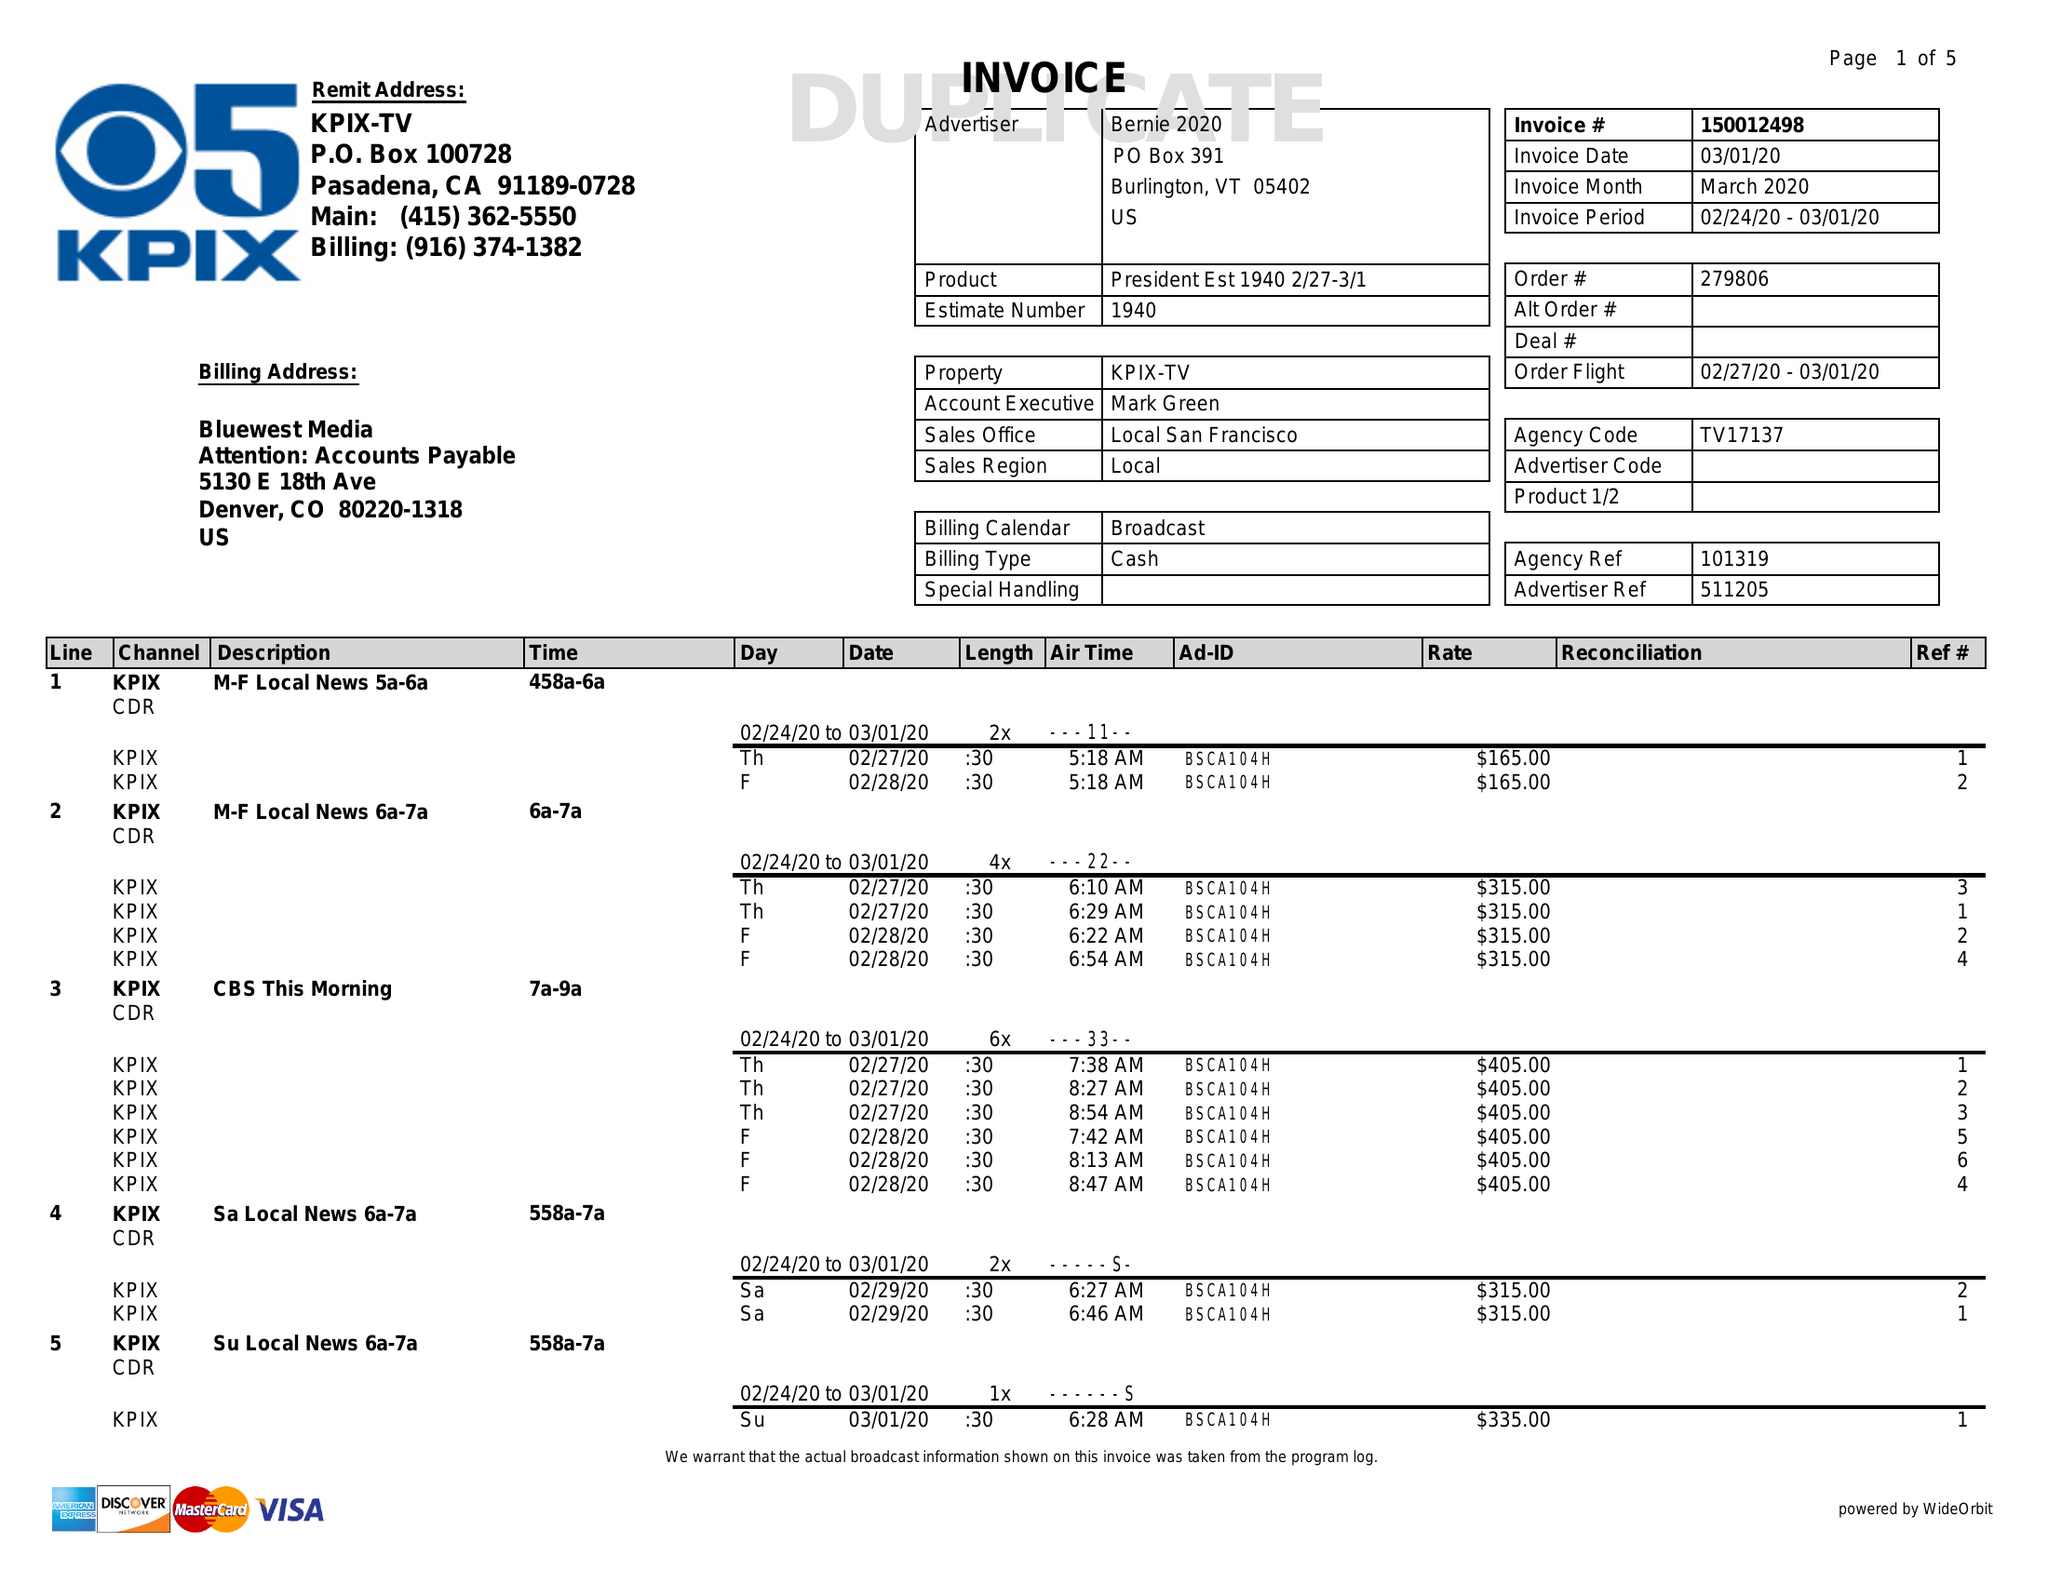What is the value for the contract_num?
Answer the question using a single word or phrase. 150012498 